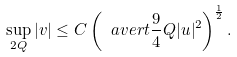Convert formula to latex. <formula><loc_0><loc_0><loc_500><loc_500>\sup _ { 2 Q } | v | \leq C \left ( \ a v e r t { \frac { 9 } { 4 } Q } | u | ^ { 2 } \right ) ^ { \frac { 1 } { 2 } } .</formula> 